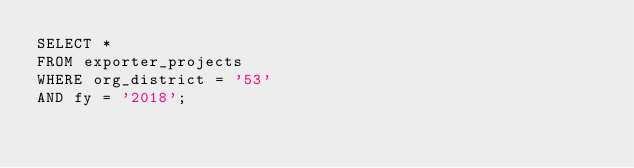Convert code to text. <code><loc_0><loc_0><loc_500><loc_500><_SQL_>SELECT *
FROM exporter_projects
WHERE org_district = '53'
AND fy = '2018';</code> 